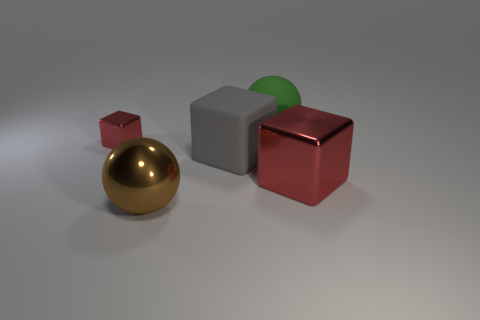Add 2 big yellow spheres. How many objects exist? 7 Subtract all balls. How many objects are left? 3 Subtract all tiny shiny cubes. Subtract all small red things. How many objects are left? 3 Add 2 green objects. How many green objects are left? 3 Add 3 yellow rubber cylinders. How many yellow rubber cylinders exist? 3 Subtract 0 gray spheres. How many objects are left? 5 